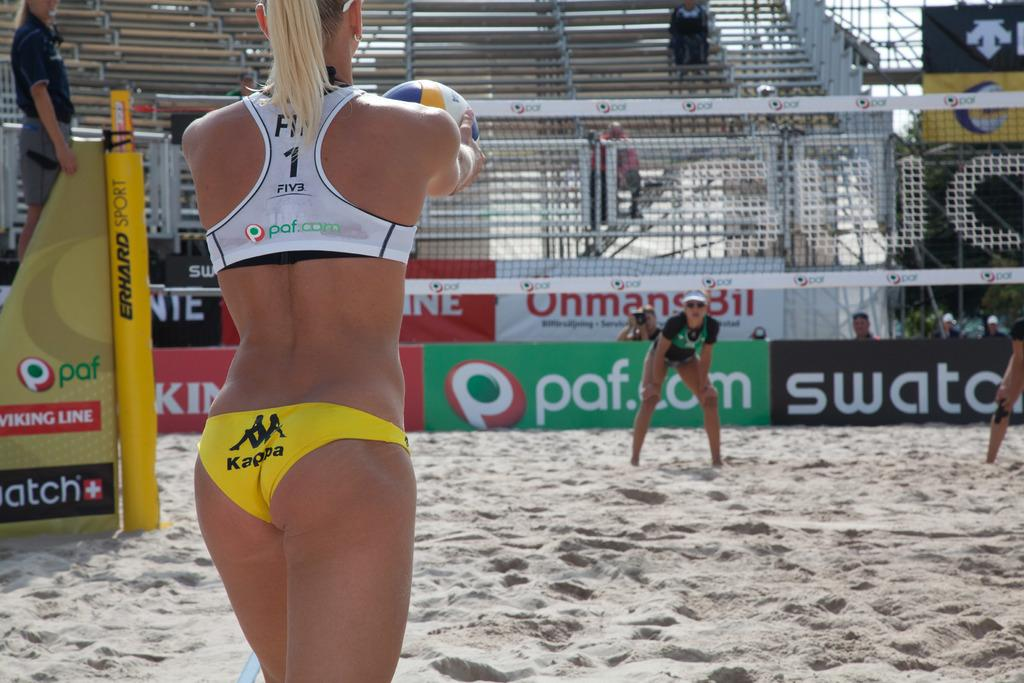<image>
Describe the image concisely. Person wearing a white top which says the number 1 on it. 